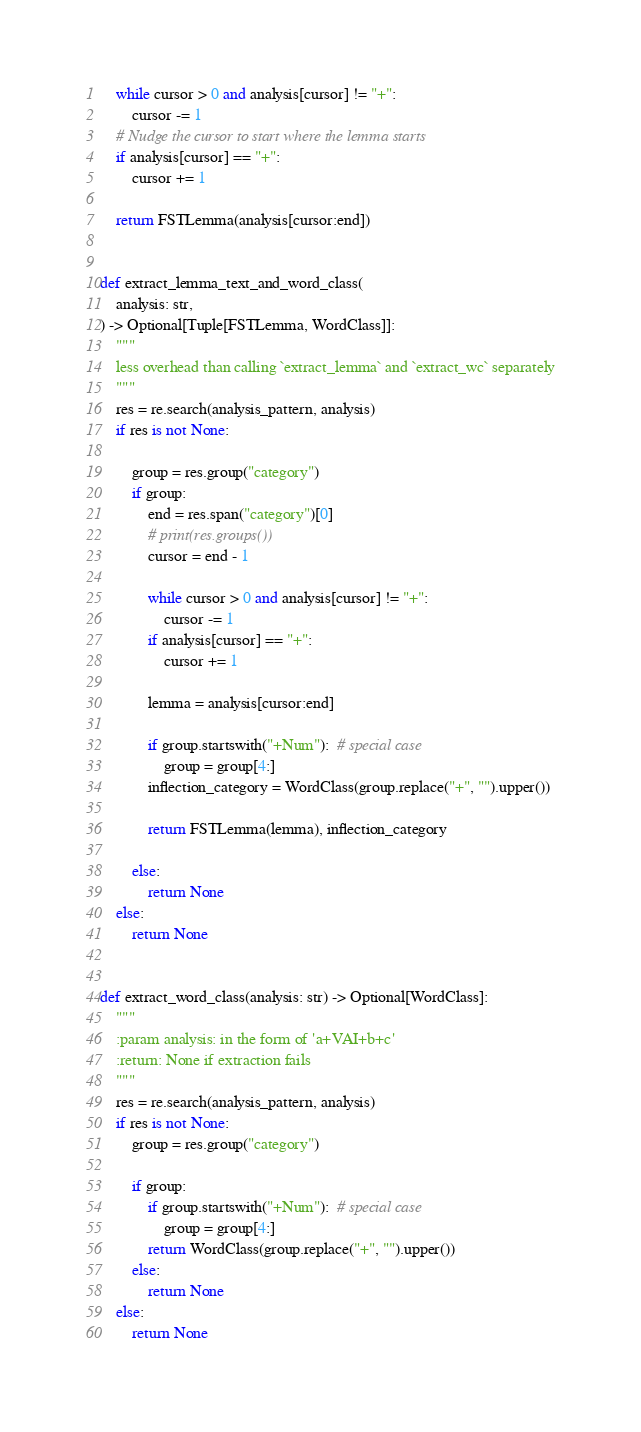Convert code to text. <code><loc_0><loc_0><loc_500><loc_500><_Python_>    while cursor > 0 and analysis[cursor] != "+":
        cursor -= 1
    # Nudge the cursor to start where the lemma starts
    if analysis[cursor] == "+":
        cursor += 1

    return FSTLemma(analysis[cursor:end])


def extract_lemma_text_and_word_class(
    analysis: str,
) -> Optional[Tuple[FSTLemma, WordClass]]:
    """
    less overhead than calling `extract_lemma` and `extract_wc` separately
    """
    res = re.search(analysis_pattern, analysis)
    if res is not None:

        group = res.group("category")
        if group:
            end = res.span("category")[0]
            # print(res.groups())
            cursor = end - 1

            while cursor > 0 and analysis[cursor] != "+":
                cursor -= 1
            if analysis[cursor] == "+":
                cursor += 1

            lemma = analysis[cursor:end]

            if group.startswith("+Num"):  # special case
                group = group[4:]
            inflection_category = WordClass(group.replace("+", "").upper())

            return FSTLemma(lemma), inflection_category

        else:
            return None
    else:
        return None


def extract_word_class(analysis: str) -> Optional[WordClass]:
    """
    :param analysis: in the form of 'a+VAI+b+c'
    :return: None if extraction fails
    """
    res = re.search(analysis_pattern, analysis)
    if res is not None:
        group = res.group("category")

        if group:
            if group.startswith("+Num"):  # special case
                group = group[4:]
            return WordClass(group.replace("+", "").upper())
        else:
            return None
    else:
        return None
</code> 